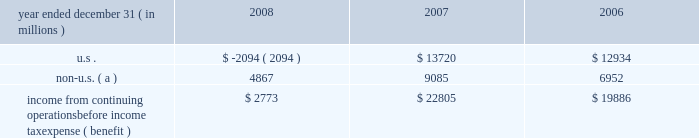Jpmorgan chase & co .
/ 2008 annual report 211 jpmorgan chase is subject to ongoing tax examinations by the tax authorities of the various jurisdictions in which it operates , including u.s .
Federal and state and non-u.s .
Jurisdictions .
The firm 2019s consoli- dated federal income tax returns are presently under examination by the internal revenue service ( 201cirs 201d ) for the years 2003 , 2004 and 2005 .
The consolidated federal income tax returns of bank one corporation , which merged with and into jpmorgan chase on july 1 , 2004 , are under examination for the years 2000 through 2003 , and for the period january 1 , 2004 , through july 1 , 2004 .
The consolidat- ed federal income tax returns of bear stearns for the years ended november 30 , 2003 , 2004 and 2005 , are also under examination .
All three examinations are expected to conclude in 2009 .
The irs audits of the consolidated federal income tax returns of jpmorgan chase for the years 2006 and 2007 , and for bear stearns for the years ended november 30 , 2006 and 2007 , are expected to commence in 2009 .
Administrative appeals are pending with the irs relating to prior examination periods .
For 2002 and prior years , refund claims relating to income and credit adjustments , and to tax attribute carry- backs , for jpmorgan chase and its predecessor entities , including bank one , have been filed .
Amended returns to reflect refund claims primarily attributable to net operating losses and tax credit carry- backs will be filed for the final bear stearns federal consolidated tax return for the period december 1 , 2007 , through may 30 , 2008 , and for prior years .
The table presents the u.s .
And non-u.s .
Components of income from continuing operations before income tax expense ( benefit ) . .
Non-u.s. ( a ) 4867 9085 6952 income from continuing operations before income tax expense ( benefit ) $ 2773 $ 22805 $ 19886 ( a ) for purposes of this table , non-u.s .
Income is defined as income generated from operations located outside the u.s .
Note 29 2013 restrictions on cash and intercom- pany funds transfers the business of jpmorgan chase bank , national association ( 201cjpmorgan chase bank , n.a . 201d ) is subject to examination and regula- tion by the office of the comptroller of the currency ( 201cocc 201d ) .
The bank is a member of the u.s .
Federal reserve system , and its deposits are insured by the fdic as discussed in note 20 on page 202 of this annual report .
The board of governors of the federal reserve system ( the 201cfederal reserve 201d ) requires depository institutions to maintain cash reserves with a federal reserve bank .
The average amount of reserve bal- ances deposited by the firm 2019s bank subsidiaries with various federal reserve banks was approximately $ 1.6 billion in 2008 and 2007 .
Restrictions imposed by u.s .
Federal law prohibit jpmorgan chase and certain of its affiliates from borrowing from banking subsidiaries unless the loans are secured in specified amounts .
Such secured loans to the firm or to other affiliates are generally limited to 10% ( 10 % ) of the banking subsidiary 2019s total capital , as determined by the risk- based capital guidelines ; the aggregate amount of all such loans is limited to 20% ( 20 % ) of the banking subsidiary 2019s total capital .
The principal sources of jpmorgan chase 2019s income ( on a parent com- pany 2013only basis ) are dividends and interest from jpmorgan chase bank , n.a. , and the other banking and nonbanking subsidiaries of jpmorgan chase .
In addition to dividend restrictions set forth in statutes and regulations , the federal reserve , the occ and the fdic have authority under the financial institutions supervisory act to pro- hibit or to limit the payment of dividends by the banking organizations they supervise , including jpmorgan chase and its subsidiaries that are banks or bank holding companies , if , in the banking regulator 2019s opin- ion , payment of a dividend would constitute an unsafe or unsound practice in light of the financial condition of the banking organization .
At january 1 , 2009 and 2008 , jpmorgan chase 2019s banking sub- sidiaries could pay , in the aggregate , $ 17.0 billion and $ 16.2 billion , respectively , in dividends to their respective bank holding companies without the prior approval of their relevant banking regulators .
The capacity to pay dividends in 2009 will be supplemented by the bank- ing subsidiaries 2019 earnings during the year .
In compliance with rules and regulations established by u.s .
And non-u.s .
Regulators , as of december 31 , 2008 and 2007 , cash in the amount of $ 20.8 billion and $ 16.0 billion , respectively , and securities with a fair value of $ 12.1 billion and $ 3.4 billion , respectively , were segregated in special bank accounts for the benefit of securities and futures brokerage customers. .
In 2008 what was the ratio of the cash to the securities in segregated bank accounts for the benefit of securities and futures brokerage customers? 
Computations: (20.8 / 12.1)
Answer: 1.71901. 